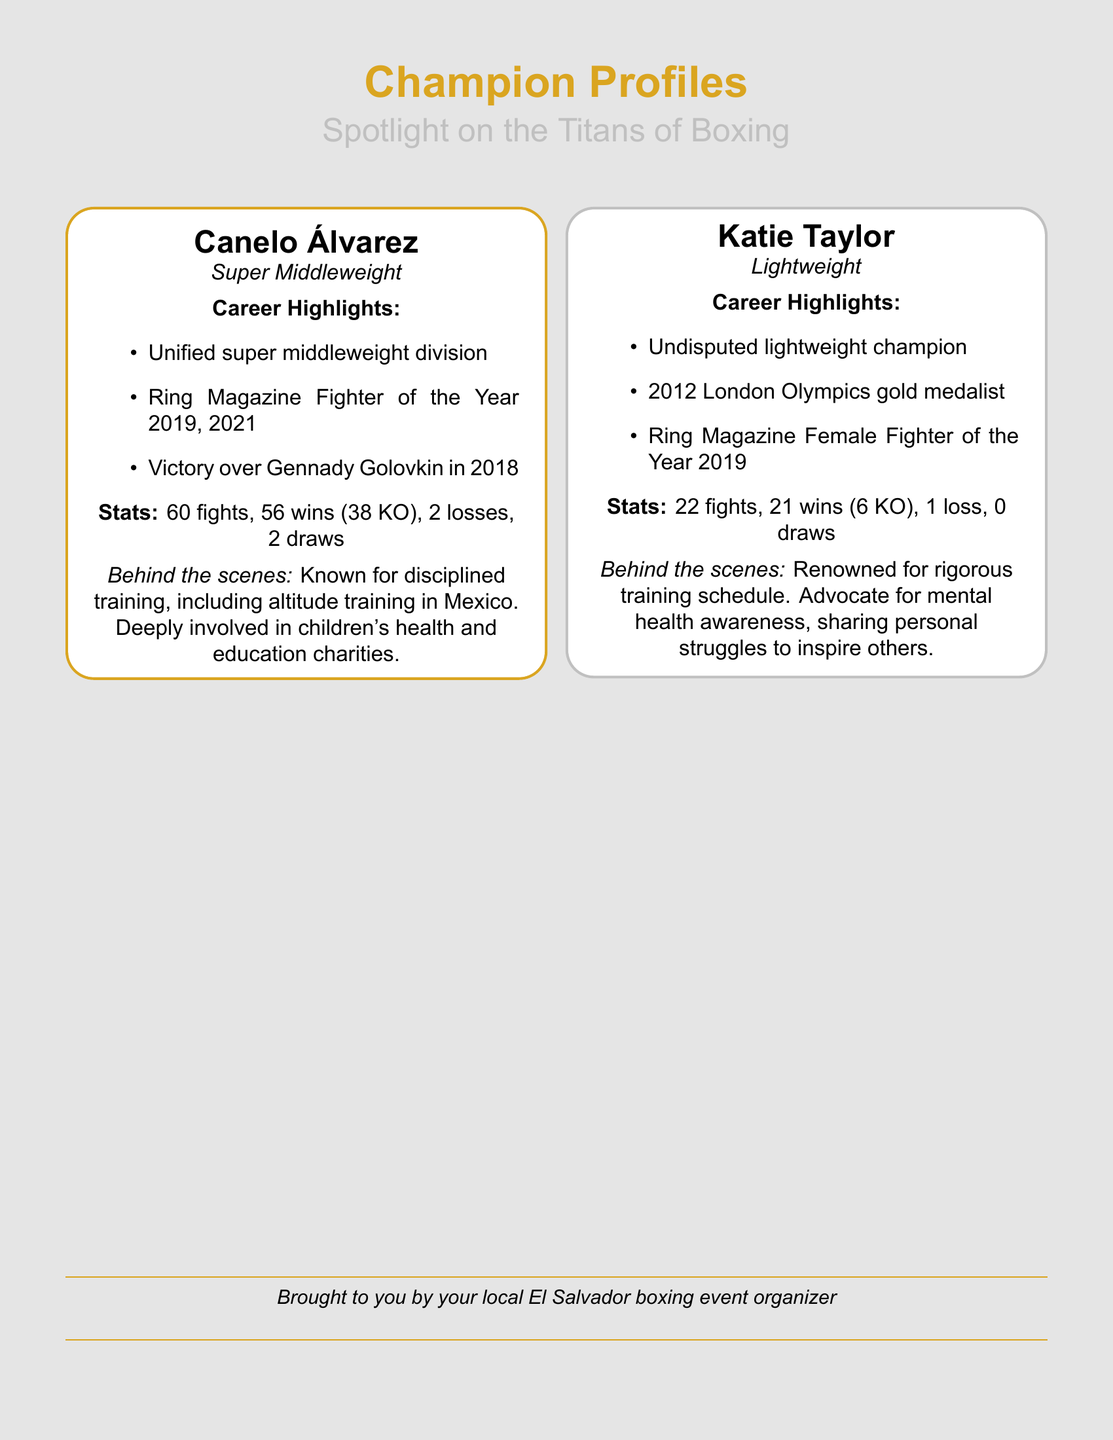What is Canelo Álvarez's weight class? The document states that Canelo Álvarez is a Super Middleweight.
Answer: Super Middleweight How many wins does Katie Taylor have? The document lists Katie Taylor's record as 21 wins.
Answer: 21 wins What year did Canelo Álvarez become Fighter of the Year according to Ring Magazine? The document mentions that he received this title in 2019 and 2021.
Answer: 2019, 2021 How many losses does Katie Taylor have in her record? The document shows that Katie Taylor has 1 loss.
Answer: 1 loss What major sporting event did Katie Taylor win a gold medal in? The document states she won a gold medal at the 2012 London Olympics.
Answer: 2012 London Olympics What does Canelo Álvarez do for charity? The document reveals that he is deeply involved in children's health and education charities.
Answer: Children's health and education charities What is Canelo Álvarez's total number of fights? The document specifies that he has had 60 fights.
Answer: 60 fights What aspect of mental health does Katie Taylor advocate for? The document notes that she shares personal struggles to inspire others regarding mental health awareness.
Answer: Mental health awareness What is a significant achievement for Katie Taylor in 2019? The document indicates that she was named Ring Magazine Female Fighter of the Year.
Answer: Ring Magazine Female Fighter of the Year 